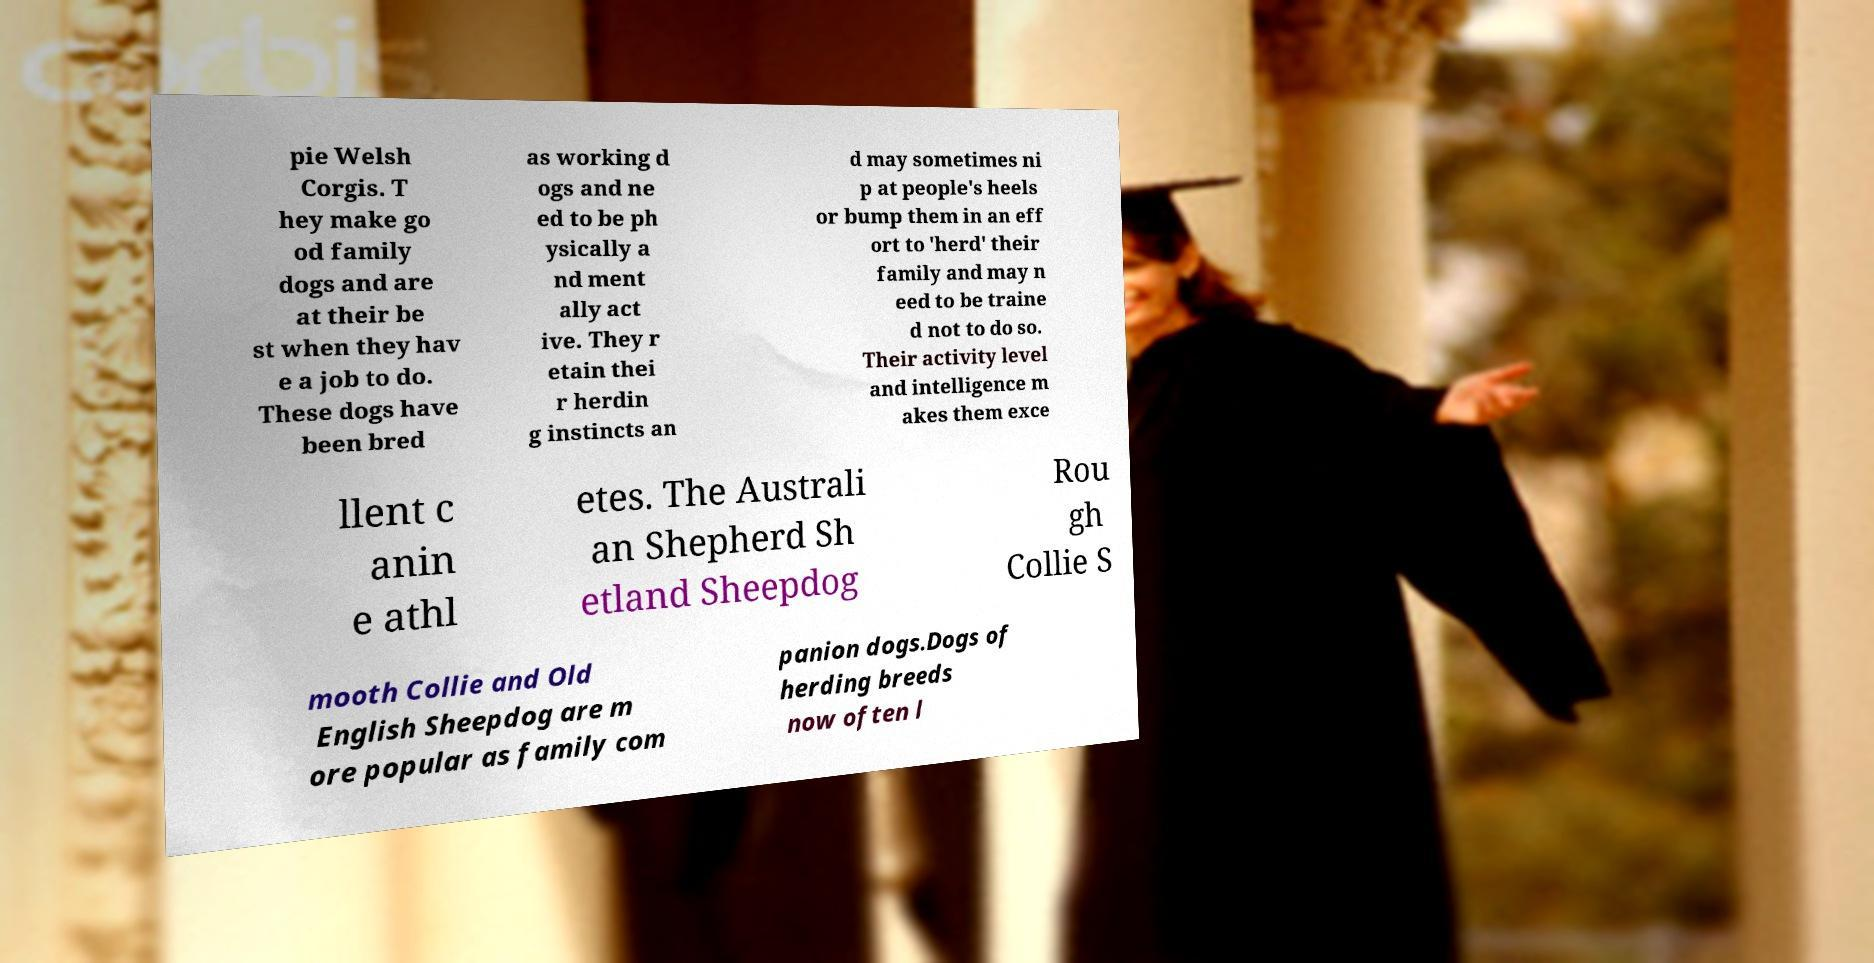Can you read and provide the text displayed in the image?This photo seems to have some interesting text. Can you extract and type it out for me? pie Welsh Corgis. T hey make go od family dogs and are at their be st when they hav e a job to do. These dogs have been bred as working d ogs and ne ed to be ph ysically a nd ment ally act ive. They r etain thei r herdin g instincts an d may sometimes ni p at people's heels or bump them in an eff ort to 'herd' their family and may n eed to be traine d not to do so. Their activity level and intelligence m akes them exce llent c anin e athl etes. The Australi an Shepherd Sh etland Sheepdog Rou gh Collie S mooth Collie and Old English Sheepdog are m ore popular as family com panion dogs.Dogs of herding breeds now often l 